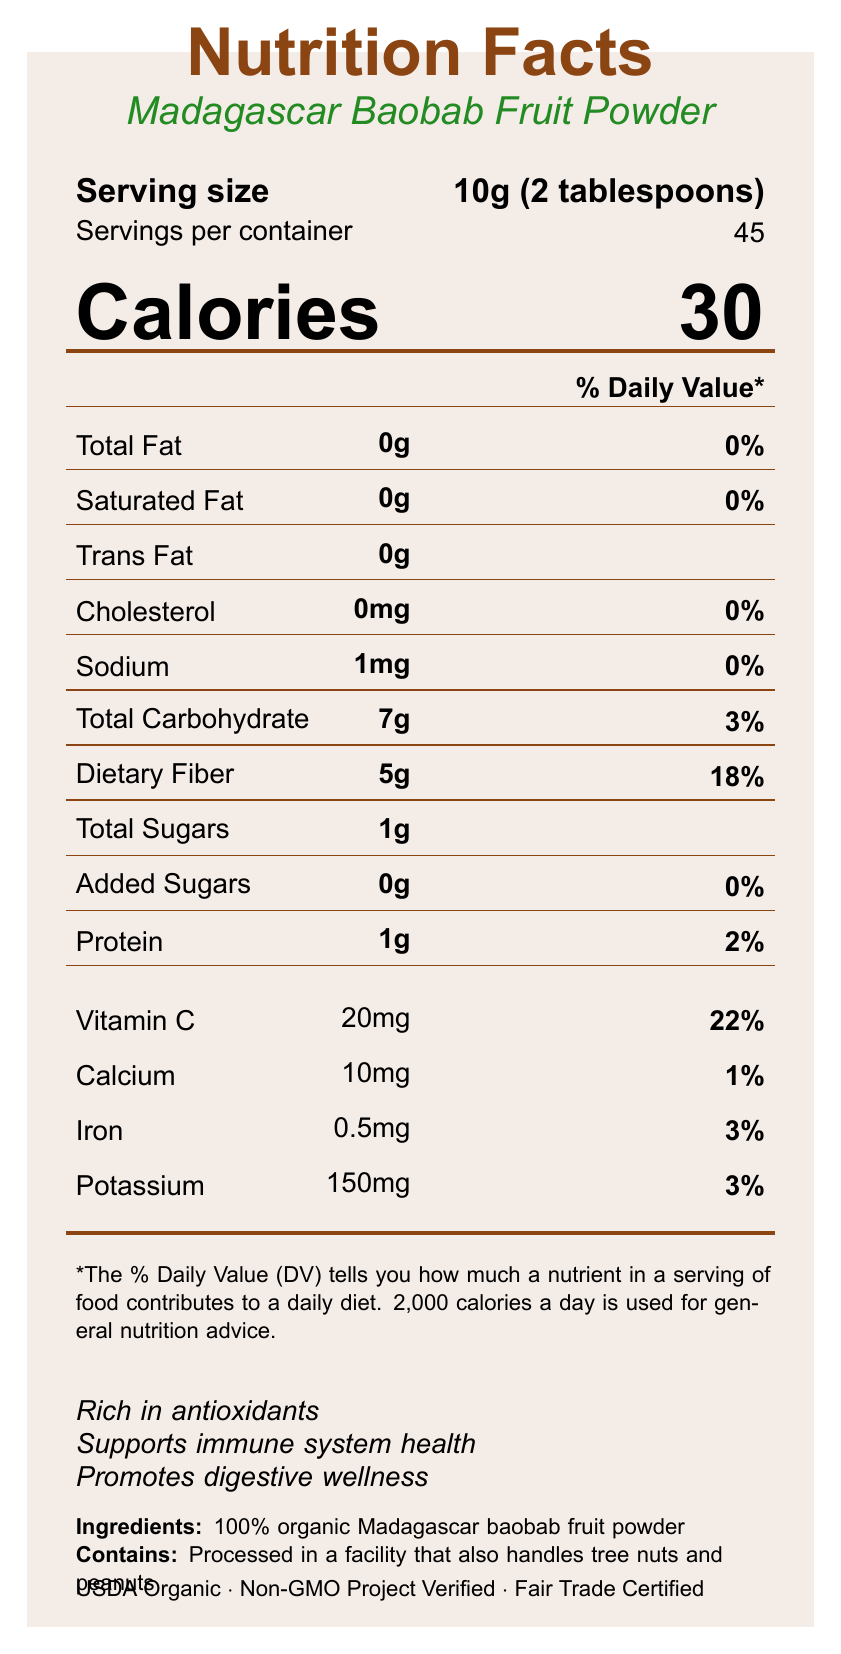what is the serving size? The serving size is clearly stated under "Serving size" in the document.
Answer: 10g (2 tablespoons) how many servings are there per container? The document lists "Servings per container" as 45.
Answer: 45 how many calories are in one serving? The document mentions "Calories" as 30 per serving.
Answer: 30 what is the total dietary fiber per serving? The "Dietary Fiber" per serving is indicated as 5g in the nutrient table.
Answer: 5g what percentage of the daily value of dietary fiber does one serving provide? The document states that the "Dietary Fiber" provides 18% of the daily value.
Answer: 18% how much vitamin C is in each serving? Each serving contains "Vitamin C" amounting to 20mg.
Answer: 20mg what is the percentage of daily recommended vitamin C found in a serving? The percentage daily value for "Vitamin C" is stated as 22%.
Answer: 22% how much calcium does one serving provide? One serving provides 10mg of calcium as listed in the nutrient details.
Answer: 10mg how much potassium is in each serving? The potassium content in each serving is 150mg, as mentioned in the nutrient table.
Answer: 150mg how much protein does a serving of the powder contain? A. 0g B. 0.5g C. 1g D. 1.5g The nutrient table shows that "Protein" per serving is 1g.
Answer: C what is the main ingredient of the product? A. Potassium B. Baobab fruit powder C. Calcium The document lists "100% organic Madagascar baobab fruit powder" as the ingredient.
Answer: B which nutrient contributes more than 10% of the daily value in one serving? A. Iron B. Vitamin C C. Calcium D. Sodium Only Vitamin C exceeds 10% of the daily value per serving, with 22%.
Answer: B is the product processed in a facility that handles tree nuts and peanuts? (Yes/No) The allergen statement on the document indicates it is processed in such a facility.
Answer: Yes briefly summarize the main nutritional benefits of the Madagascar Baobab Fruit Powder. The document highlights the high fiber (5g) and vitamin C (20mg) content per serving and includes additional information about the product’s health benefits.
Answer: The Madagascar Baobab Fruit Powder is high in dietary fiber and vitamin C, and it supports immune system health, promotes digestive wellness, and is rich in antioxidants. what certifications does the Madagascar Baobab Fruit Powder hold? This information is listed under the certifications section near the bottom of the document.
Answer: USDA Organic, Non-GMO Project Verified, Fair Trade Certified what is the amount of added sugars per serving? The nutrient table clearly states that there are 0g of added sugars.
Answer: 0g how much iron is in one serving? The document specifies that each serving contains 0.5mg of iron.
Answer: 0.5mg who is the importer of the Madagascar Baobab Fruit Powder? The importer information provided indicates it is imported by the Madagascar Embassy Cultural Affairs Office.
Answer: Madagascar Embassy Cultural Affairs Office, Washington D.C. does the baobab fruit powder have any trans fat content per serving? The nutrient table lists trans fat content as 0g per serving.
Answer: 0g is there any information on the price of the product? The document does not provide any information regarding the price of the product.
Answer: Cannot be determined 